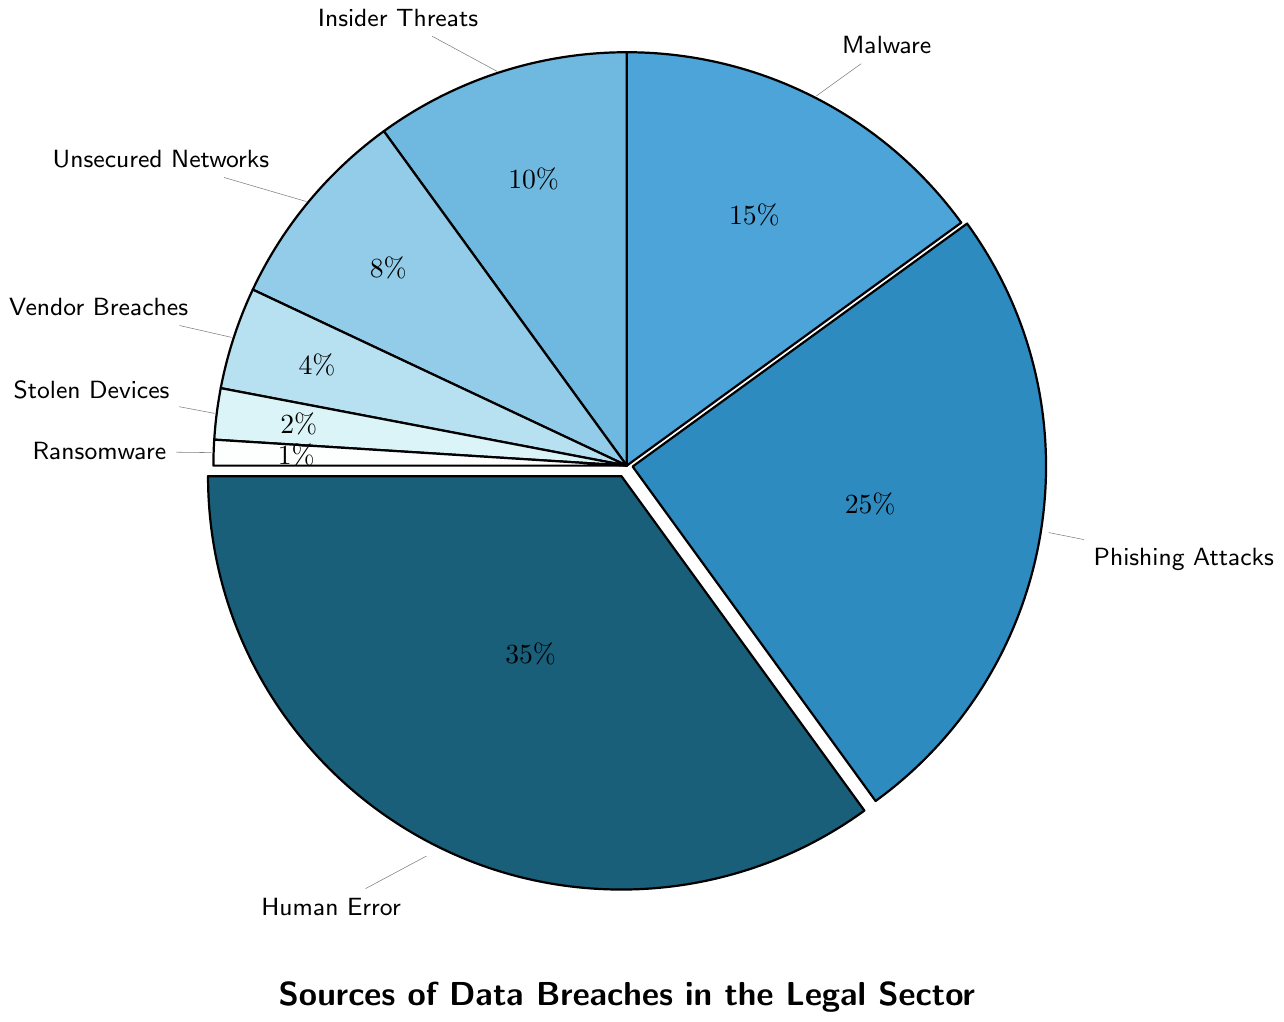What's the largest source of data breaches in the legal sector? To determine the largest source of data breaches, we look for the segment with the highest percentage. The pie chart shows that "Human Error" takes up the largest portion with 35%.
Answer: Human Error Between "Phishing Attacks" and "Malware," which contributes more to data breaches in the legal sector? Compare the percentages of "Phishing Attacks" and "Malware". Phishing Attacks has 25%, while Malware has 15%. Thus, Phishing Attacks contributes more.
Answer: Phishing Attacks How much more does "Human Error" contribute to data breaches compared to "Insider Threats"? Subtract the percentage of "Insider Threats" from "Human Error" (35% - 10%). This results in a difference of 25%.
Answer: 25% What percentage of data breaches can be attributed to both "Unsecured Networks" and "Vendor Breaches" combined? To find the combined percentage of "Unsecured Networks" and "Vendor Breaches," add their percentages (8% + 4%). The sum is 12%.
Answer: 12% If "Stolen Devices" and "Ransomware" combined increased by 5%, what would their total percentage be? First, add the current percentages of "Stolen Devices" and "Ransomware" (2% + 1% = 3%). Then add the 5% increase to this sum (3% + 5%). The new total is 8%.
Answer: 8% Among "Malware," "Unsecured Networks," and "Vendor Breaches," which has the lowest contribution to data breaches? Compare the percentages of "Malware" (15%), "Unsecured Networks" (8%), and "Vendor Breaches" (4%). "Vendor Breaches" has the lowest contribution.
Answer: Vendor Breaches By how much do "Phishing Attacks" exceed "Malware" in their contribution to data breaches? Subtract the percentage of "Malware" from that of "Phishing Attacks" (25% - 15%). This gives a difference of 10%.
Answer: 10% What is the total percentage for data breaches attributed to sources with less than 10% contribution each? Identify the sources with less than 10%: "Unsecured Networks" (8%), "Vendor Breaches" (4%), "Stolen Devices" (2%), and "Ransomware" (1%). Sum these percentages (8% + 4% + 2% + 1%). The total is 15%.
Answer: 15% What color represents "Malware" in the pie chart? Visually inspect the color used for the segment labeled "Malware." The color associated with "Malware" appears to be a shade of blue.
Answer: Shade of blue 